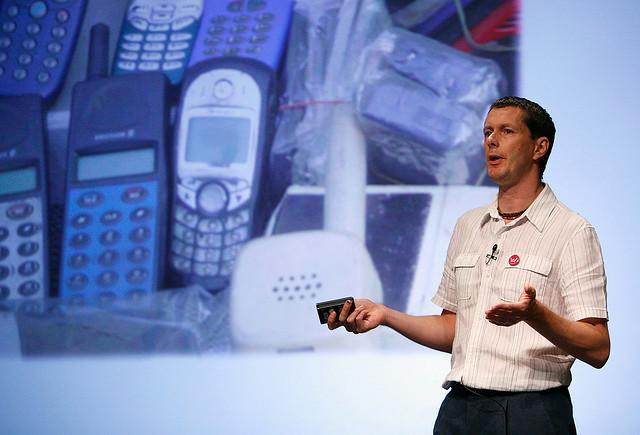What is the subject of the speech being given? cell phones 